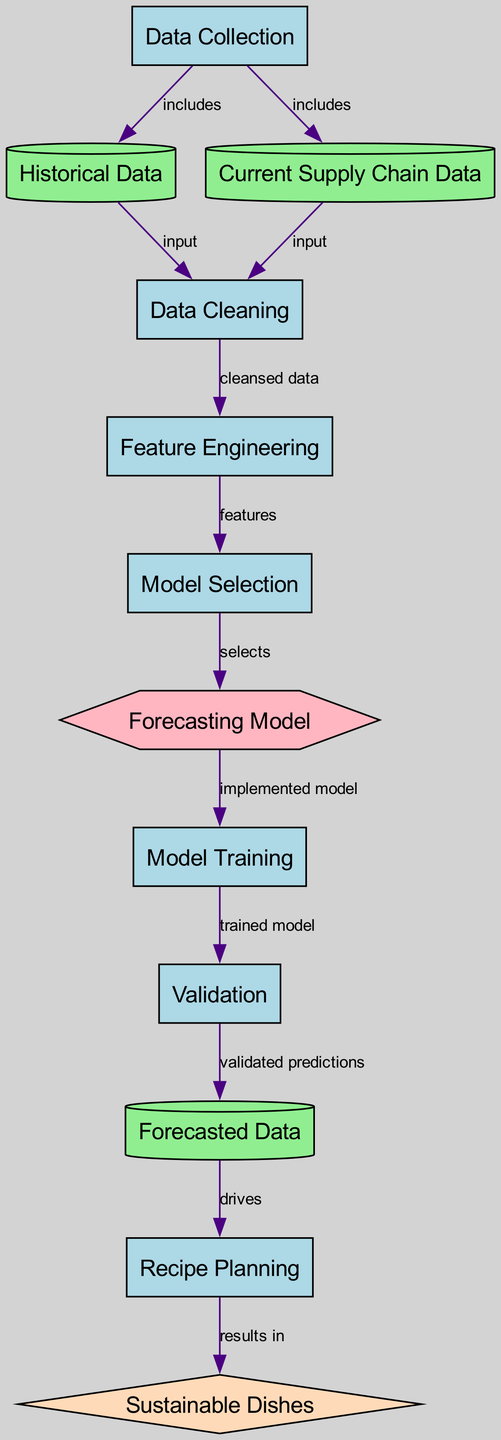What is the first process in the diagram? The diagram starts with the "Data Collection" process, which is the first node listed and has arrows directed from it to other nodes.
Answer: Data Collection How many data nodes are present in the diagram? There are three data nodes: "Historical Data", "Current Supply Chain Data", and "Forecasted Data".
Answer: 3 What process follows data cleaning in the diagram? After "Data Cleaning", the next process is "Feature Engineering", indicated by an edge leading from cleaning to engineering.
Answer: Feature Engineering Which algorithm is implemented for forecasting? The "Forecasting Model" node indicates that ARIMA, LSTM, and other models can be implemented as indicated by the description under this node.
Answer: Forecasting Model What outcome results from recipe planning? The final outcome from "Recipe Planning" is "Sustainable Dishes", shown by the edge leading from planning to the outcome node.
Answer: Sustainable Dishes How does validated model affect forecasted data? The "Validation" process provides "validated predictions" that directly influence the subsequent node, "Forecasted Data", as indicated by the connecting edge.
Answer: Validated predictions What stage involves selecting the best forecasting model? The stage where the best model is selected is denoted as "Model Selection", connecting from the "Feature Engineering" node.
Answer: Model Selection How many edges are there in the diagram? There are twelve edges listed, which connect the various nodes, indicating the relationships and flow between processes, data, and outcomes.
Answer: 12 What data drives the recipe planning process? The "Forecasted Data" drives "Recipe Planning", as represented by the directed edge showing this relationship in the diagram.
Answer: Forecasted Data 